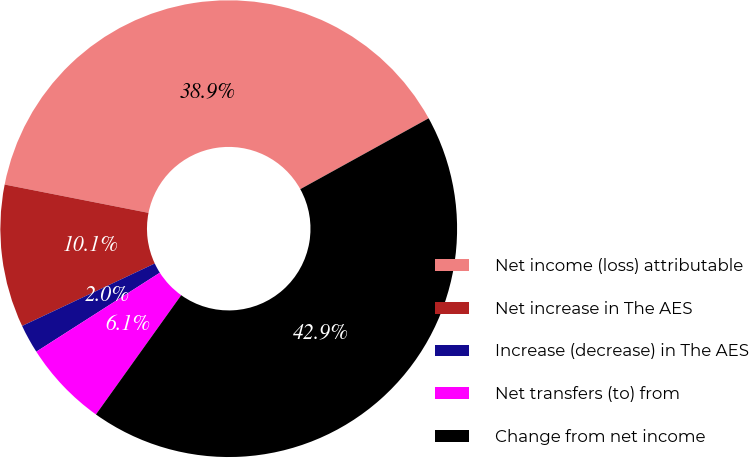Convert chart to OTSL. <chart><loc_0><loc_0><loc_500><loc_500><pie_chart><fcel>Net income (loss) attributable<fcel>Net increase in The AES<fcel>Increase (decrease) in The AES<fcel>Net transfers (to) from<fcel>Change from net income<nl><fcel>38.88%<fcel>10.1%<fcel>2.05%<fcel>6.07%<fcel>42.91%<nl></chart> 